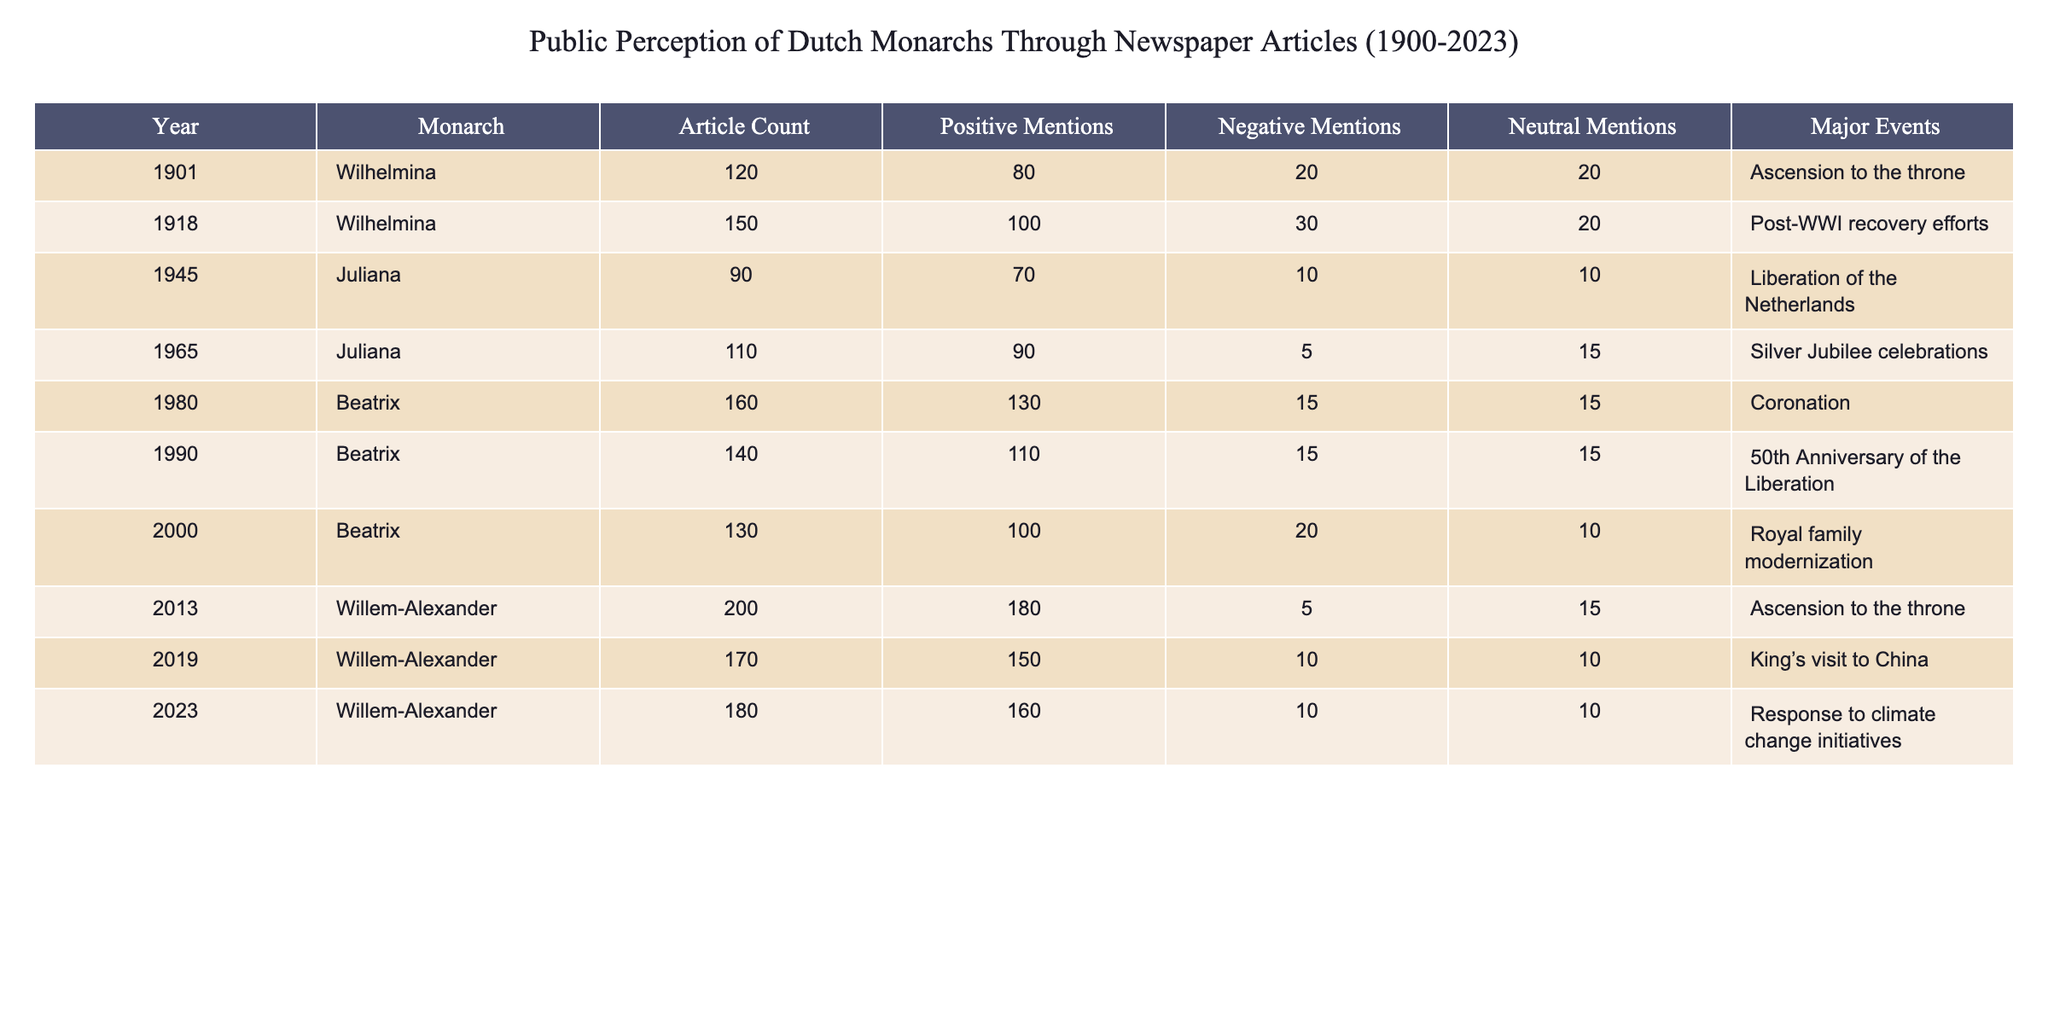What was the article count for Juliana in 1965? The table shows the row for Juliana in 1965, which specifies an article count of 110.
Answer: 110 How many positive mentions did Beatrix receive in 1990? Referring to the row for Beatrix in 1990, it indicates there were 110 positive mentions.
Answer: 110 What is the total number of articles mentioning Willem-Alexander from 2013 to 2023? To find the total articles for Willem-Alexander, I sum the article counts from 2013 (200), 2019 (170), and 2023 (180), which gives 200 + 170 + 180 = 550 articles.
Answer: 550 Was there an increase or decrease in positive mentions for Wilhelmina from 1901 to 1918? From the table, Wilhelmina had 80 positive mentions in 1901 and 100 in 1918. Since 100 is greater than 80, there was an increase.
Answer: Increase In which year did Beatrix have the least negative mentions throughout her reign in the table? Looking at the entries for Beatrix, the negative mentions were 15 in both 1980 and 1990, but 5 in 1965, which is the least. Thus, Beatrix had the least negative mentions in 1965.
Answer: 1965 What was the average number of negative mentions across all monarchs in the years provided? To calculate the average, I add up all negative mentions: (20 + 30 + 10 + 5 + 15 + 15 + 20 + 5 + 10 + 10) = 140. There are 10 entries, so the average is 140 / 10 = 14.
Answer: 14 Did Juliana receive more positive mentions in 1945 or in 1965? Juliana had 70 positive mentions in 1945 and 90 in 1965. Since 90 is greater than 70, she received more positive mentions in 1965.
Answer: 1965 What was the difference in article counts between Beatrix in 1980 and Juliana in 1965? Beatrix had 160 articles in 1980 and Juliana had 110 articles in 1965. The difference is 160 - 110 = 50 articles.
Answer: 50 Which monarch had the highest article count in any single year? By examining the article counts, Willem-Alexander had the highest at 200 articles in 2013.
Answer: 200 